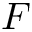<formula> <loc_0><loc_0><loc_500><loc_500>F</formula> 